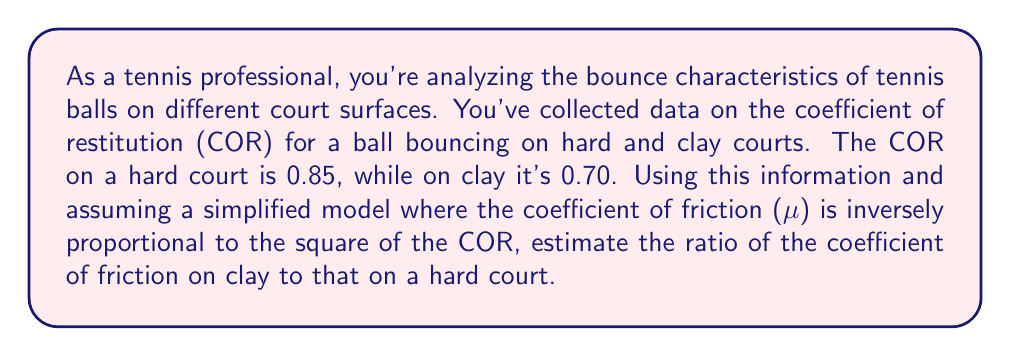Can you solve this math problem? Let's approach this step-by-step:

1) We're given that the coefficient of friction (μ) is inversely proportional to the square of the coefficient of restitution (COR). This can be expressed mathematically as:

   $$ \mu \propto \frac{1}{COR^2} $$

2) Let's denote the coefficient of friction on hard court as $\mu_h$ and on clay court as $\mu_c$. Similarly, let's use $COR_h$ for hard court and $COR_c$ for clay court.

3) We can write the proportionality as equations:

   $$ \mu_h = k \cdot \frac{1}{COR_h^2} $$
   $$ \mu_c = k \cdot \frac{1}{COR_c^2} $$

   Where $k$ is some constant of proportionality.

4) To find the ratio of $\mu_c$ to $\mu_h$, we divide these equations:

   $$ \frac{\mu_c}{\mu_h} = \frac{k \cdot \frac{1}{COR_c^2}}{k \cdot \frac{1}{COR_h^2}} $$

5) The constant $k$ cancels out:

   $$ \frac{\mu_c}{\mu_h} = \frac{COR_h^2}{COR_c^2} $$

6) Now we can plug in the given values:
   $COR_h = 0.85$ (hard court)
   $COR_c = 0.70$ (clay court)

   $$ \frac{\mu_c}{\mu_h} = \frac{0.85^2}{0.70^2} $$

7) Calculate:

   $$ \frac{\mu_c}{\mu_h} = \frac{0.7225}{0.49} \approx 1.4745 $$

Therefore, the coefficient of friction on clay is approximately 1.4745 times that on a hard court.
Answer: 1.4745 